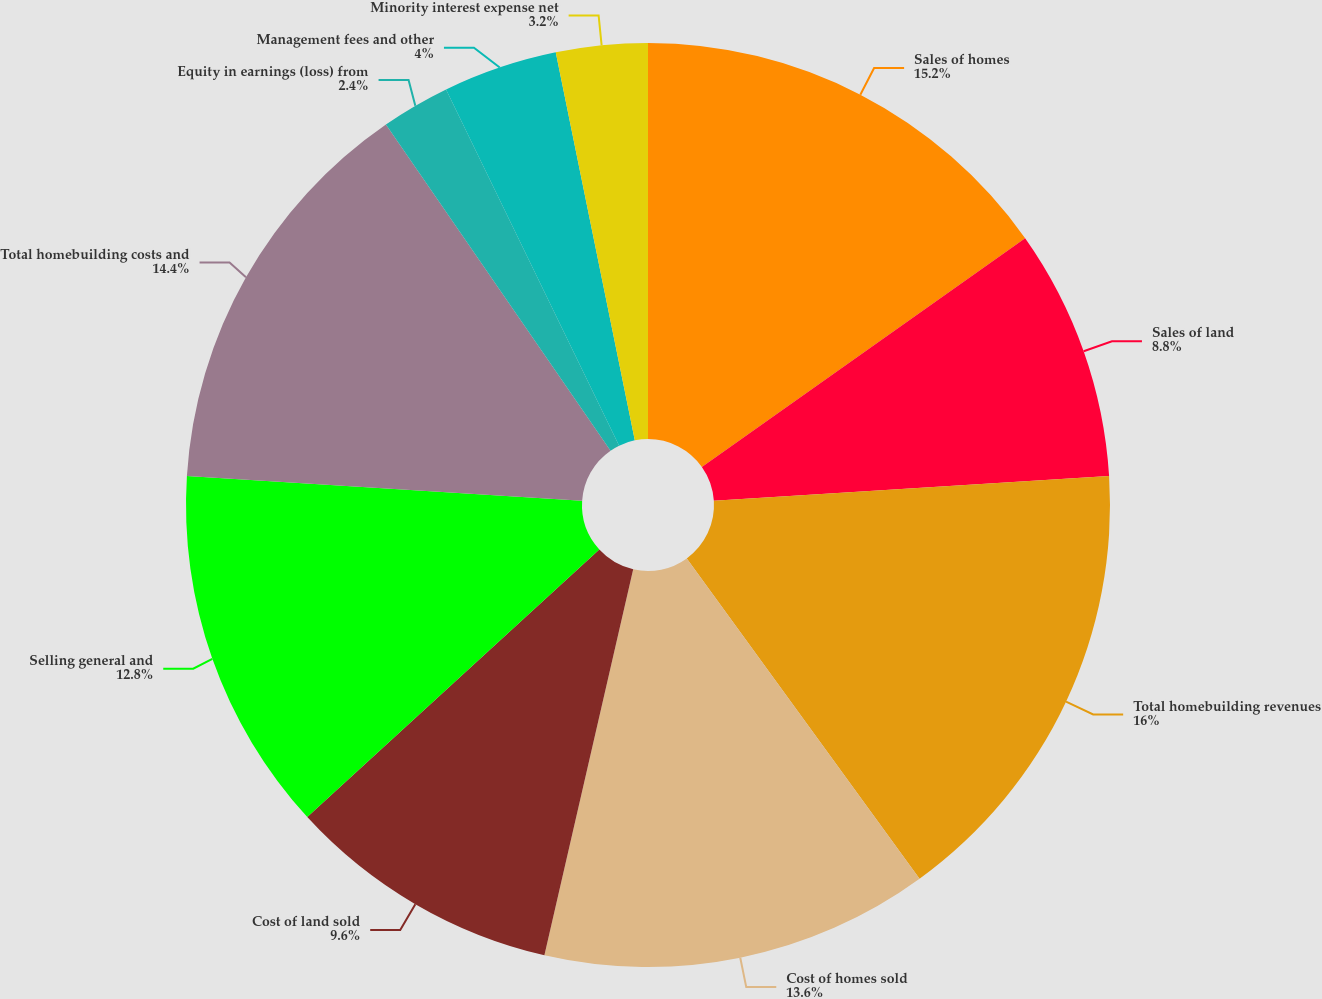Convert chart to OTSL. <chart><loc_0><loc_0><loc_500><loc_500><pie_chart><fcel>Sales of homes<fcel>Sales of land<fcel>Total homebuilding revenues<fcel>Cost of homes sold<fcel>Cost of land sold<fcel>Selling general and<fcel>Total homebuilding costs and<fcel>Equity in earnings (loss) from<fcel>Management fees and other<fcel>Minority interest expense net<nl><fcel>15.2%<fcel>8.8%<fcel>16.0%<fcel>13.6%<fcel>9.6%<fcel>12.8%<fcel>14.4%<fcel>2.4%<fcel>4.0%<fcel>3.2%<nl></chart> 